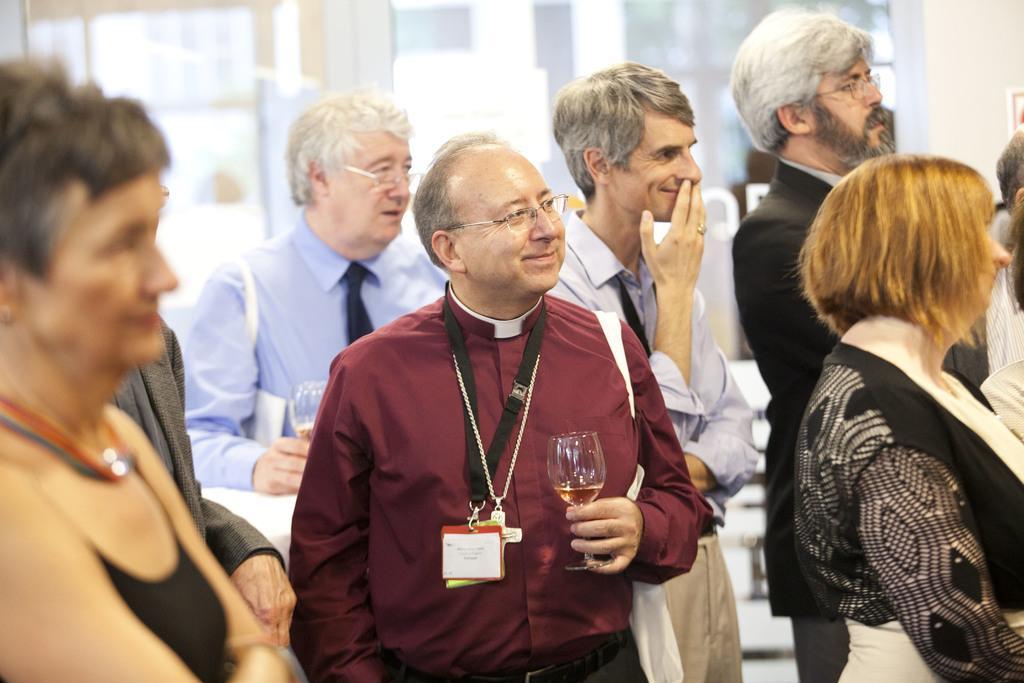Can you describe this image briefly? In this image we can see people standing and some of them are holding glasses. In the background there is a wall. 